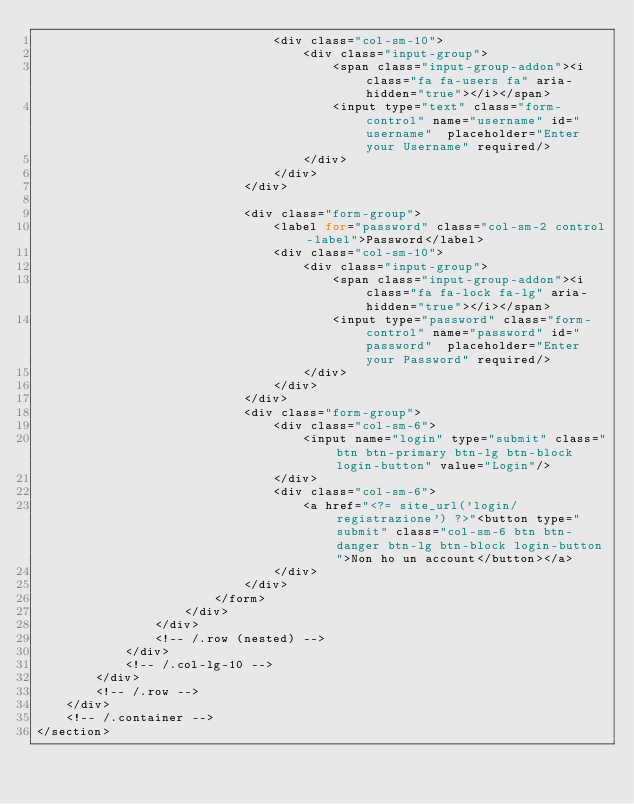<code> <loc_0><loc_0><loc_500><loc_500><_PHP_>                                <div class="col-sm-10">
                                    <div class="input-group">
                                        <span class="input-group-addon"><i class="fa fa-users fa" aria-hidden="true"></i></span>
                                        <input type="text" class="form-control" name="username" id="username"  placeholder="Enter your Username" required/>
                                    </div>
                                </div>
                            </div>

                            <div class="form-group">
                                <label for="password" class="col-sm-2 control-label">Password</label>
                                <div class="col-sm-10">
                                    <div class="input-group">
                                        <span class="input-group-addon"><i class="fa fa-lock fa-lg" aria-hidden="true"></i></span>
                                        <input type="password" class="form-control" name="password" id="password"  placeholder="Enter your Password" required/>
                                    </div>
                                </div>
                            </div>
                            <div class="form-group">
                                <div class="col-sm-6">
                                    <input name="login" type="submit" class="btn btn-primary btn-lg btn-block login-button" value="Login"/>
                                </div>
                                <div class="col-sm-6">
                                    <a href="<?= site_url('login/registrazione') ?>"<button type="submit" class="col-sm-6 btn btn-danger btn-lg btn-block login-button">Non ho un account</button></a>
                                </div>
                            </div>
                        </form>
                    </div>
                </div>
                <!-- /.row (nested) -->
            </div>
            <!-- /.col-lg-10 -->
        </div>
        <!-- /.row -->
    </div>
    <!-- /.container -->
</section></code> 